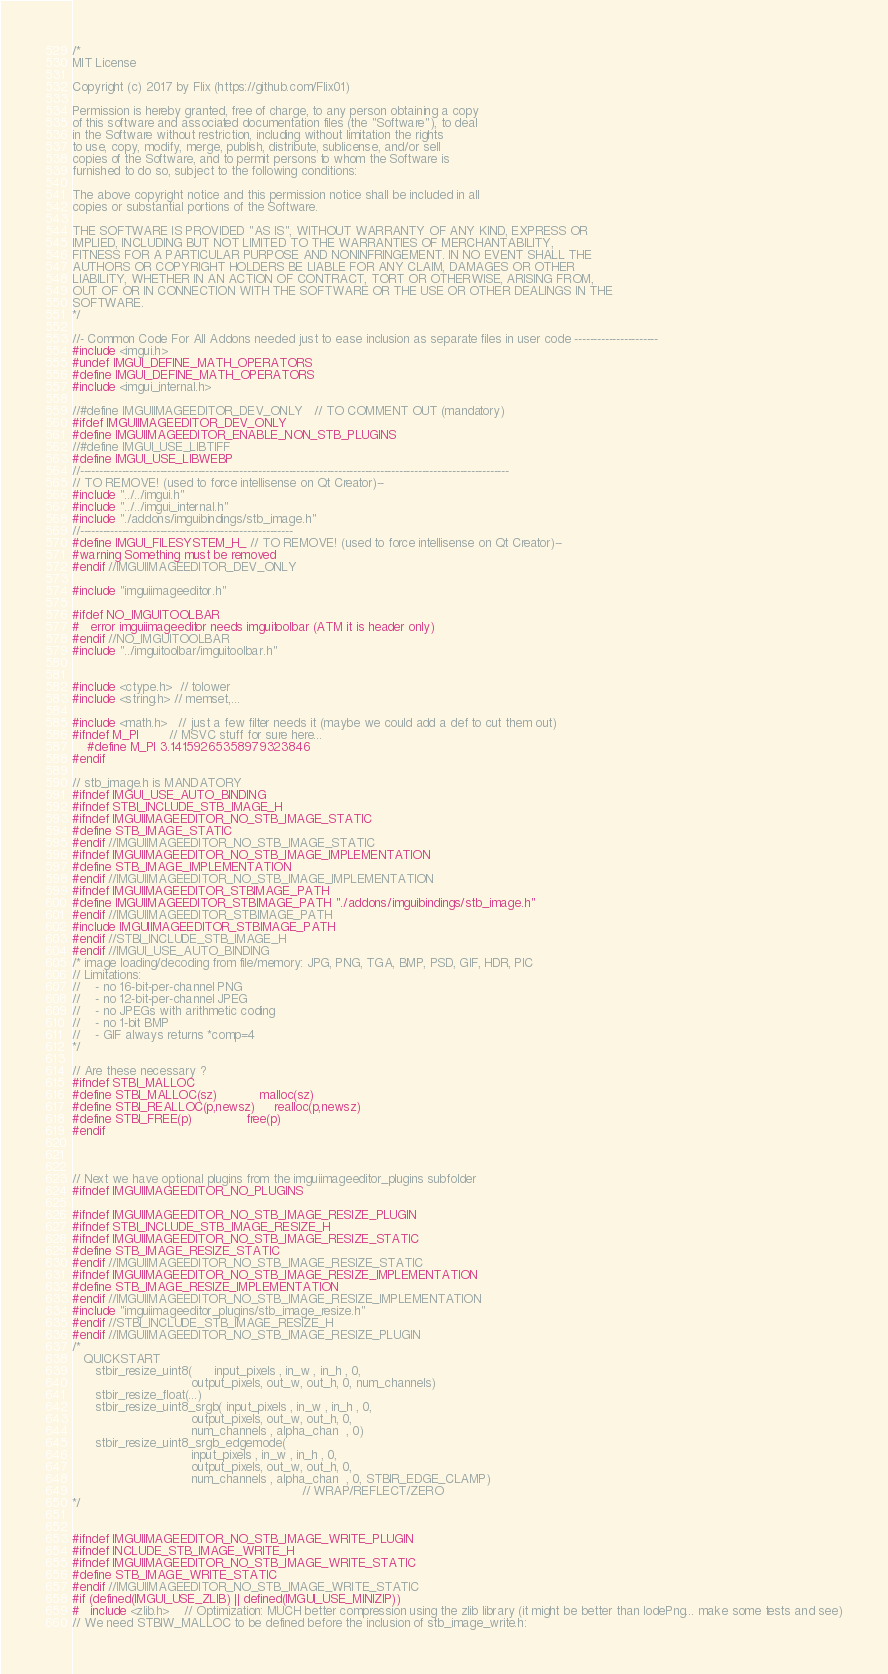Convert code to text. <code><loc_0><loc_0><loc_500><loc_500><_C++_>/*
MIT License

Copyright (c) 2017 by Flix (https://github.com/Flix01)

Permission is hereby granted, free of charge, to any person obtaining a copy
of this software and associated documentation files (the "Software"), to deal
in the Software without restriction, including without limitation the rights
to use, copy, modify, merge, publish, distribute, sublicense, and/or sell
copies of the Software, and to permit persons to whom the Software is
furnished to do so, subject to the following conditions:

The above copyright notice and this permission notice shall be included in all
copies or substantial portions of the Software.

THE SOFTWARE IS PROVIDED "AS IS", WITHOUT WARRANTY OF ANY KIND, EXPRESS OR
IMPLIED, INCLUDING BUT NOT LIMITED TO THE WARRANTIES OF MERCHANTABILITY,
FITNESS FOR A PARTICULAR PURPOSE AND NONINFRINGEMENT. IN NO EVENT SHALL THE
AUTHORS OR COPYRIGHT HOLDERS BE LIABLE FOR ANY CLAIM, DAMAGES OR OTHER
LIABILITY, WHETHER IN AN ACTION OF CONTRACT, TORT OR OTHERWISE, ARISING FROM,
OUT OF OR IN CONNECTION WITH THE SOFTWARE OR THE USE OR OTHER DEALINGS IN THE
SOFTWARE.
*/

//- Common Code For All Addons needed just to ease inclusion as separate files in user code ----------------------
#include <imgui.h>
#undef IMGUI_DEFINE_MATH_OPERATORS
#define IMGUI_DEFINE_MATH_OPERATORS
#include <imgui_internal.h>

//#define IMGUIIMAGEEDITOR_DEV_ONLY   // TO COMMENT OUT (mandatory)
#ifdef IMGUIIMAGEEDITOR_DEV_ONLY
#define IMGUIIMAGEEDITOR_ENABLE_NON_STB_PLUGINS
//#define IMGUI_USE_LIBTIFF
#define IMGUI_USE_LIBWEBP
//-----------------------------------------------------------------------------------------------------------------
// TO REMOVE! (used to force intellisense on Qt Creator)--
#include "../../imgui.h"
#include "../../imgui_internal.h"
#include "./addons/imguibindings/stb_image.h"
//--------------------------------------------------------
#define IMGUI_FILESYSTEM_H_ // TO REMOVE! (used to force intellisense on Qt Creator)--
#warning Something must be removed
#endif //IMGUIIMAGEEDITOR_DEV_ONLY

#include "imguiimageeditor.h"

#ifdef NO_IMGUITOOLBAR
#   error imguiimageeditor needs imguitoolbar (ATM it is header only)
#endif //NO_IMGUITOOLBAR
#include "../imguitoolbar/imguitoolbar.h"


#include <ctype.h>  // tolower
#include <string.h> // memset,...

#include <math.h>   // just a few filter needs it (maybe we could add a def to cut them out)
#ifndef M_PI        // MSVC stuff for sure here...
    #define M_PI 3.14159265358979323846
#endif

// stb_image.h is MANDATORY
#ifndef IMGUI_USE_AUTO_BINDING
#ifndef STBI_INCLUDE_STB_IMAGE_H
#ifndef IMGUIIMAGEEDITOR_NO_STB_IMAGE_STATIC
#define STB_IMAGE_STATIC
#endif //IMGUIIMAGEEDITOR_NO_STB_IMAGE_STATIC
#ifndef IMGUIIMAGEEDITOR_NO_STB_IMAGE_IMPLEMENTATION
#define STB_IMAGE_IMPLEMENTATION
#endif //IMGUIIMAGEEDITOR_NO_STB_IMAGE_IMPLEMENTATION
#ifndef IMGUIIMAGEEDITOR_STBIMAGE_PATH
#define IMGUIIMAGEEDITOR_STBIMAGE_PATH "./addons/imguibindings/stb_image.h"
#endif //IMGUIIMAGEEDITOR_STBIMAGE_PATH
#include IMGUIIMAGEEDITOR_STBIMAGE_PATH
#endif //STBI_INCLUDE_STB_IMAGE_H
#endif //IMGUI_USE_AUTO_BINDING
/* image loading/decoding from file/memory: JPG, PNG, TGA, BMP, PSD, GIF, HDR, PIC
// Limitations:
//    - no 16-bit-per-channel PNG
//    - no 12-bit-per-channel JPEG
//    - no JPEGs with arithmetic coding
//    - no 1-bit BMP
//    - GIF always returns *comp=4
*/

// Are these necessary ?
#ifndef STBI_MALLOC
#define STBI_MALLOC(sz)           malloc(sz)
#define STBI_REALLOC(p,newsz)     realloc(p,newsz)
#define STBI_FREE(p)              free(p)
#endif



// Next we have optional plugins from the imguiimageeditor_plugins subfolder
#ifndef IMGUIIMAGEEDITOR_NO_PLUGINS

#ifndef IMGUIIMAGEEDITOR_NO_STB_IMAGE_RESIZE_PLUGIN
#ifndef STBI_INCLUDE_STB_IMAGE_RESIZE_H
#ifndef IMGUIIMAGEEDITOR_NO_STB_IMAGE_RESIZE_STATIC
#define STB_IMAGE_RESIZE_STATIC
#endif //IMGUIIMAGEEDITOR_NO_STB_IMAGE_RESIZE_STATIC
#ifndef IMGUIIMAGEEDITOR_NO_STB_IMAGE_RESIZE_IMPLEMENTATION
#define STB_IMAGE_RESIZE_IMPLEMENTATION
#endif //IMGUIIMAGEEDITOR_NO_STB_IMAGE_RESIZE_IMPLEMENTATION
#include "imguiimageeditor_plugins/stb_image_resize.h"
#endif //STBI_INCLUDE_STB_IMAGE_RESIZE_H
#endif //IMGUIIMAGEEDITOR_NO_STB_IMAGE_RESIZE_PLUGIN
/*
   QUICKSTART
      stbir_resize_uint8(      input_pixels , in_w , in_h , 0,
                               output_pixels, out_w, out_h, 0, num_channels)
      stbir_resize_float(...)
      stbir_resize_uint8_srgb( input_pixels , in_w , in_h , 0,
                               output_pixels, out_w, out_h, 0,
                               num_channels , alpha_chan  , 0)
      stbir_resize_uint8_srgb_edgemode(
                               input_pixels , in_w , in_h , 0,
                               output_pixels, out_w, out_h, 0,
                               num_channels , alpha_chan  , 0, STBIR_EDGE_CLAMP)
                                                            // WRAP/REFLECT/ZERO
*/


#ifndef IMGUIIMAGEEDITOR_NO_STB_IMAGE_WRITE_PLUGIN
#ifndef INCLUDE_STB_IMAGE_WRITE_H
#ifndef IMGUIIMAGEEDITOR_NO_STB_IMAGE_WRITE_STATIC
#define STB_IMAGE_WRITE_STATIC
#endif //IMGUIIMAGEEDITOR_NO_STB_IMAGE_WRITE_STATIC
#if (defined(IMGUI_USE_ZLIB) || defined(IMGUI_USE_MINIZIP))
#   include <zlib.h>    // Optimization: MUCH better compression using the zlib library (it might be better than lodePng... make some tests and see)
// We need STBIW_MALLOC to be defined before the inclusion of stb_image_write.h:</code> 